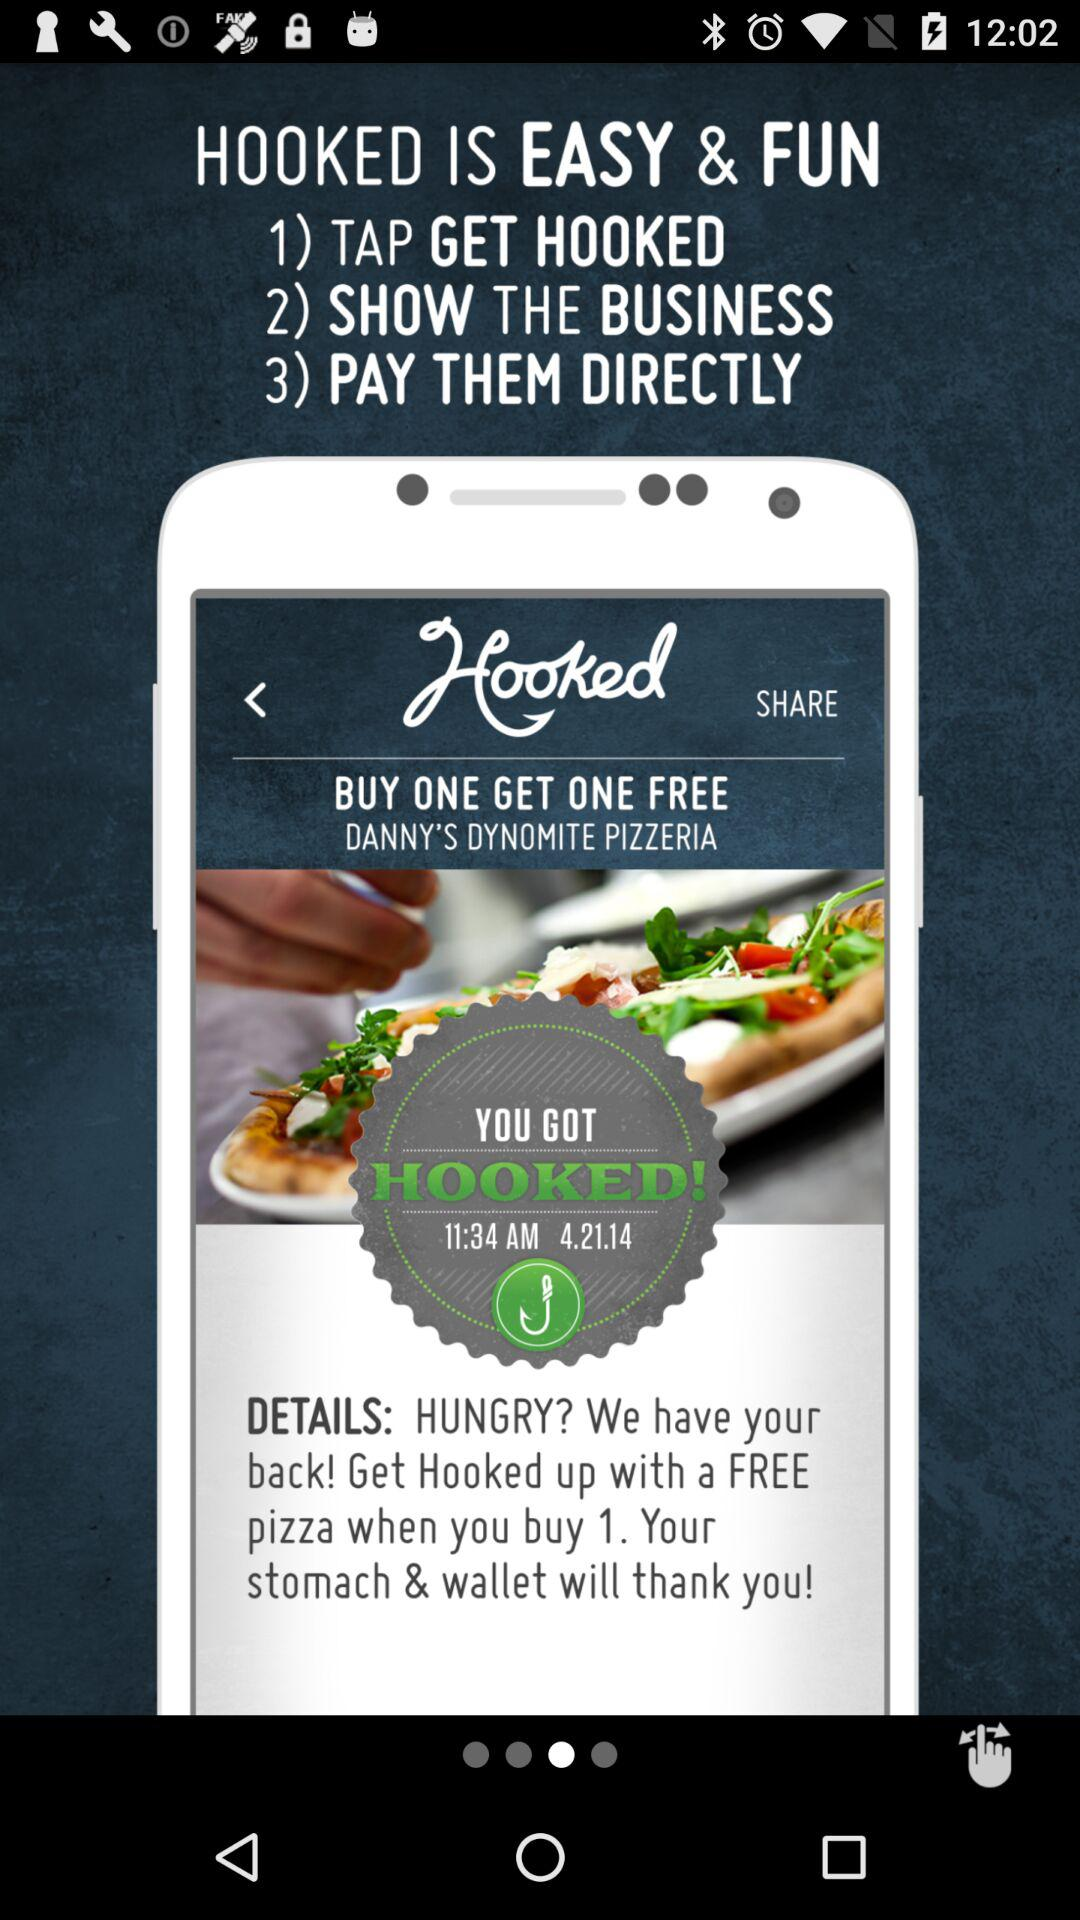What is the app name? The app name is "Hooked". 